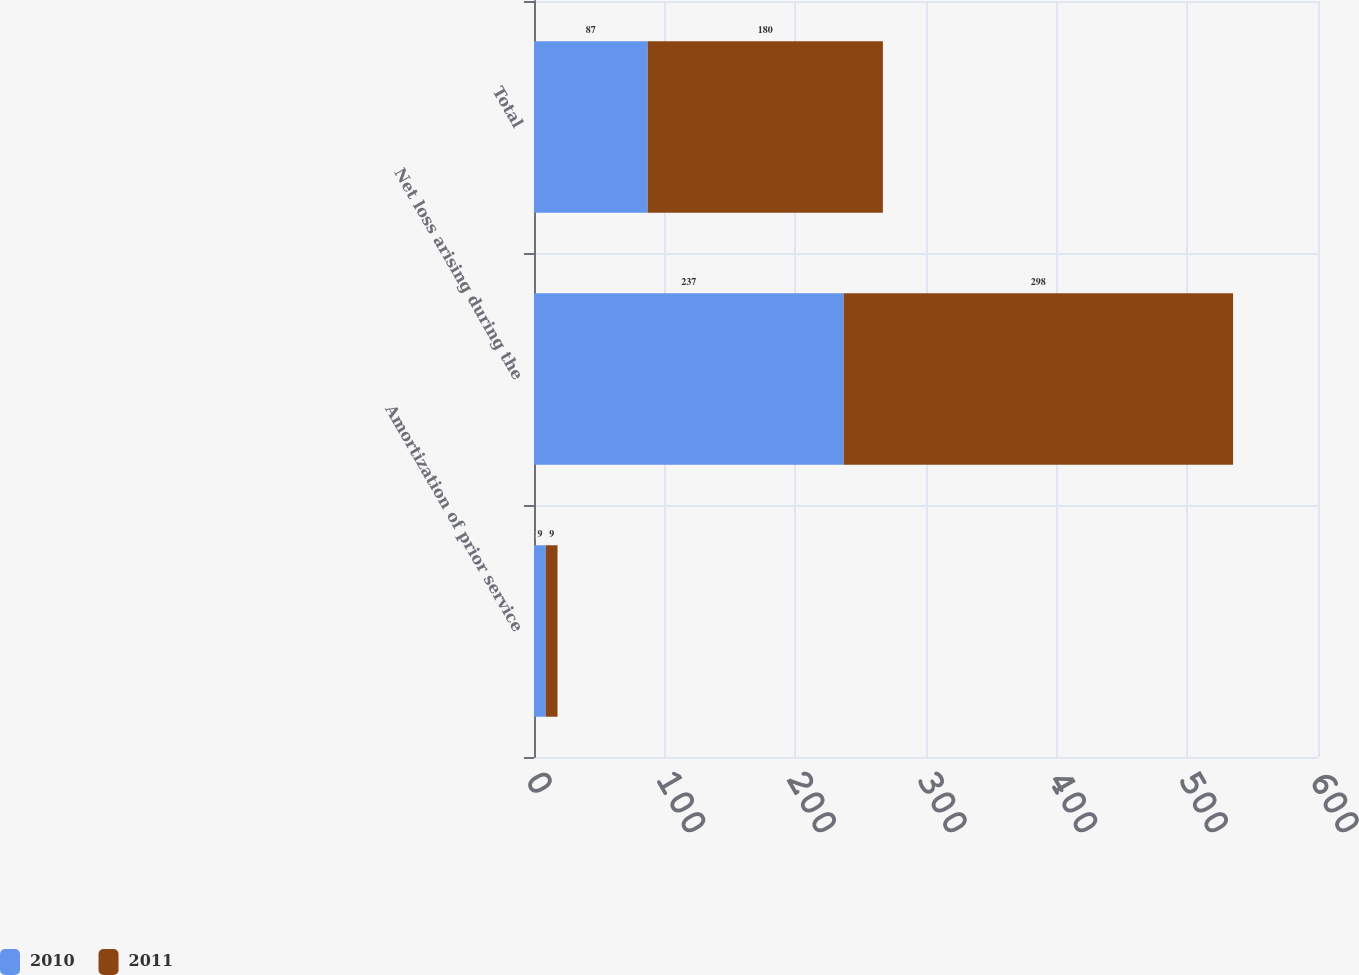Convert chart to OTSL. <chart><loc_0><loc_0><loc_500><loc_500><stacked_bar_chart><ecel><fcel>Amortization of prior service<fcel>Net loss arising during the<fcel>Total<nl><fcel>2010<fcel>9<fcel>237<fcel>87<nl><fcel>2011<fcel>9<fcel>298<fcel>180<nl></chart> 